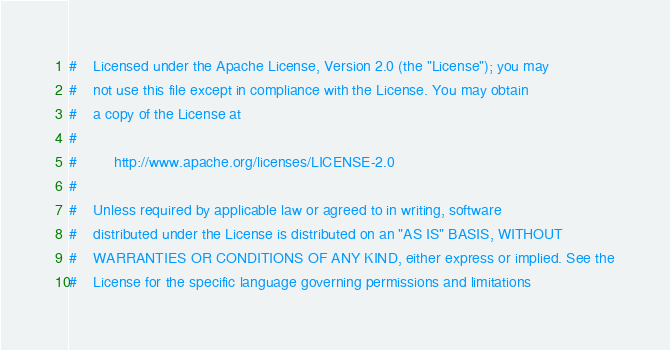Convert code to text. <code><loc_0><loc_0><loc_500><loc_500><_Python_>#    Licensed under the Apache License, Version 2.0 (the "License"); you may
#    not use this file except in compliance with the License. You may obtain
#    a copy of the License at
#
#         http://www.apache.org/licenses/LICENSE-2.0
#
#    Unless required by applicable law or agreed to in writing, software
#    distributed under the License is distributed on an "AS IS" BASIS, WITHOUT
#    WARRANTIES OR CONDITIONS OF ANY KIND, either express or implied. See the
#    License for the specific language governing permissions and limitations</code> 